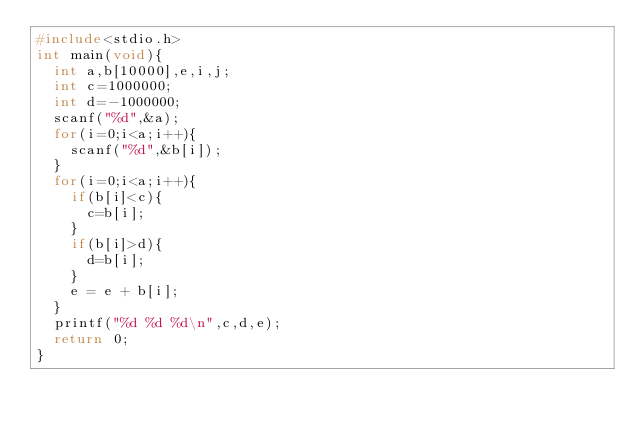Convert code to text. <code><loc_0><loc_0><loc_500><loc_500><_C_>#include<stdio.h>
int main(void){
	int a,b[10000],e,i,j;
	int c=1000000;
	int d=-1000000;
	scanf("%d",&a);
	for(i=0;i<a;i++){
		scanf("%d",&b[i]);
	}
	for(i=0;i<a;i++){
		if(b[i]<c){
			c=b[i];
		}
		if(b[i]>d){
			d=b[i];
		}
		e = e + b[i];
	}
	printf("%d %d %d\n",c,d,e);
	return 0;
}</code> 